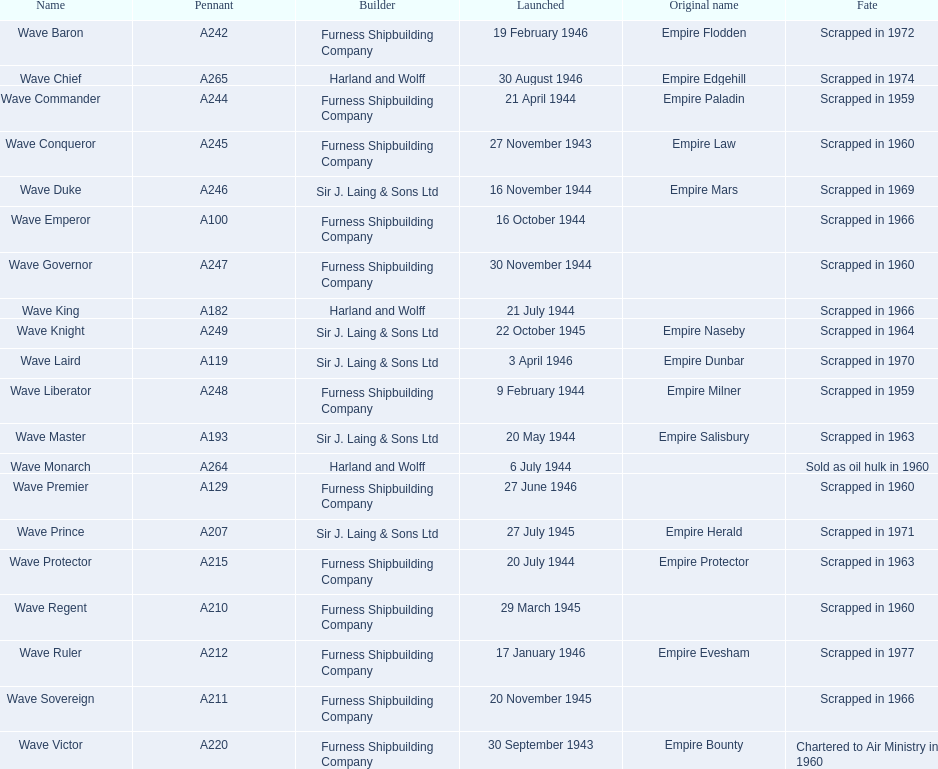In any year, which constructors released ships in november? Furness Shipbuilding Company, Sir J. Laing & Sons Ltd, Furness Shipbuilding Company, Furness Shipbuilding Company. Which ship constructors had their ships' original names modified before being taken apart? Furness Shipbuilding Company, Sir J. Laing & Sons Ltd. Could you parse the entire table as a dict? {'header': ['Name', 'Pennant', 'Builder', 'Launched', 'Original name', 'Fate'], 'rows': [['Wave Baron', 'A242', 'Furness Shipbuilding Company', '19 February 1946', 'Empire Flodden', 'Scrapped in 1972'], ['Wave Chief', 'A265', 'Harland and Wolff', '30 August 1946', 'Empire Edgehill', 'Scrapped in 1974'], ['Wave Commander', 'A244', 'Furness Shipbuilding Company', '21 April 1944', 'Empire Paladin', 'Scrapped in 1959'], ['Wave Conqueror', 'A245', 'Furness Shipbuilding Company', '27 November 1943', 'Empire Law', 'Scrapped in 1960'], ['Wave Duke', 'A246', 'Sir J. Laing & Sons Ltd', '16 November 1944', 'Empire Mars', 'Scrapped in 1969'], ['Wave Emperor', 'A100', 'Furness Shipbuilding Company', '16 October 1944', '', 'Scrapped in 1966'], ['Wave Governor', 'A247', 'Furness Shipbuilding Company', '30 November 1944', '', 'Scrapped in 1960'], ['Wave King', 'A182', 'Harland and Wolff', '21 July 1944', '', 'Scrapped in 1966'], ['Wave Knight', 'A249', 'Sir J. Laing & Sons Ltd', '22 October 1945', 'Empire Naseby', 'Scrapped in 1964'], ['Wave Laird', 'A119', 'Sir J. Laing & Sons Ltd', '3 April 1946', 'Empire Dunbar', 'Scrapped in 1970'], ['Wave Liberator', 'A248', 'Furness Shipbuilding Company', '9 February 1944', 'Empire Milner', 'Scrapped in 1959'], ['Wave Master', 'A193', 'Sir J. Laing & Sons Ltd', '20 May 1944', 'Empire Salisbury', 'Scrapped in 1963'], ['Wave Monarch', 'A264', 'Harland and Wolff', '6 July 1944', '', 'Sold as oil hulk in 1960'], ['Wave Premier', 'A129', 'Furness Shipbuilding Company', '27 June 1946', '', 'Scrapped in 1960'], ['Wave Prince', 'A207', 'Sir J. Laing & Sons Ltd', '27 July 1945', 'Empire Herald', 'Scrapped in 1971'], ['Wave Protector', 'A215', 'Furness Shipbuilding Company', '20 July 1944', 'Empire Protector', 'Scrapped in 1963'], ['Wave Regent', 'A210', 'Furness Shipbuilding Company', '29 March 1945', '', 'Scrapped in 1960'], ['Wave Ruler', 'A212', 'Furness Shipbuilding Company', '17 January 1946', 'Empire Evesham', 'Scrapped in 1977'], ['Wave Sovereign', 'A211', 'Furness Shipbuilding Company', '20 November 1945', '', 'Scrapped in 1966'], ['Wave Victor', 'A220', 'Furness Shipbuilding Company', '30 September 1943', 'Empire Bounty', 'Chartered to Air Ministry in 1960']]} What was the designation of the ship that was made in november, had its name altered before demolition, and it took place merely 12 years post-launch? Wave Conqueror. 